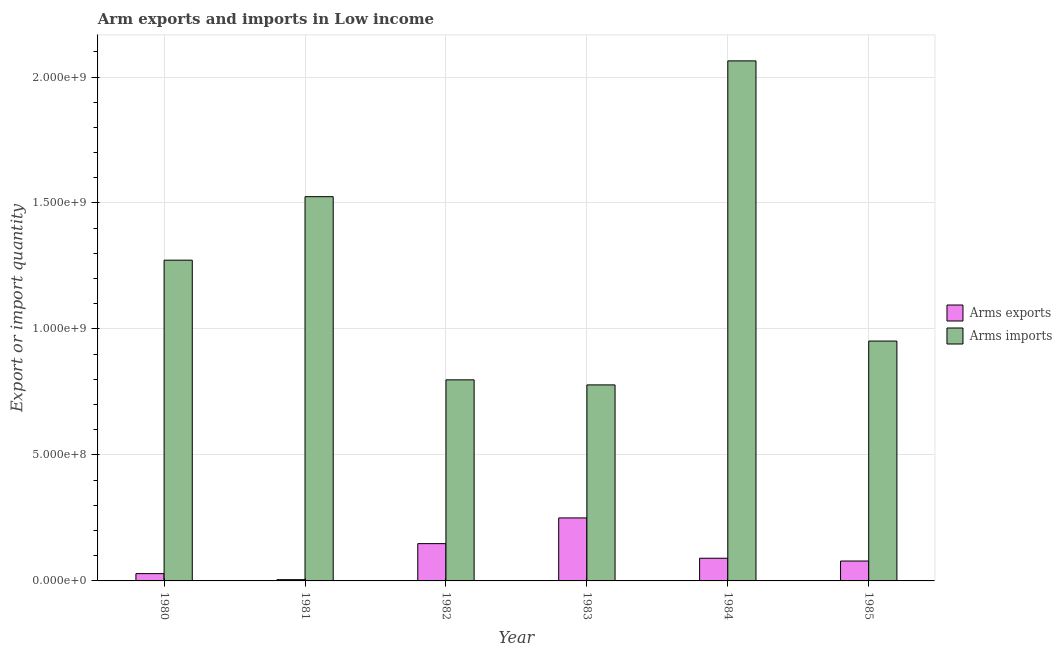How many different coloured bars are there?
Offer a very short reply. 2. How many groups of bars are there?
Make the answer very short. 6. Are the number of bars per tick equal to the number of legend labels?
Give a very brief answer. Yes. What is the label of the 6th group of bars from the left?
Your answer should be very brief. 1985. In how many cases, is the number of bars for a given year not equal to the number of legend labels?
Provide a short and direct response. 0. What is the arms exports in 1981?
Give a very brief answer. 5.00e+06. Across all years, what is the maximum arms imports?
Give a very brief answer. 2.06e+09. Across all years, what is the minimum arms exports?
Make the answer very short. 5.00e+06. In which year was the arms exports maximum?
Give a very brief answer. 1983. What is the total arms exports in the graph?
Your answer should be compact. 6.01e+08. What is the difference between the arms exports in 1980 and that in 1983?
Ensure brevity in your answer.  -2.21e+08. What is the difference between the arms imports in 1984 and the arms exports in 1982?
Ensure brevity in your answer.  1.27e+09. What is the average arms exports per year?
Your response must be concise. 1.00e+08. In how many years, is the arms exports greater than 900000000?
Make the answer very short. 0. What is the ratio of the arms imports in 1982 to that in 1985?
Keep it short and to the point. 0.84. Is the difference between the arms imports in 1980 and 1984 greater than the difference between the arms exports in 1980 and 1984?
Provide a short and direct response. No. What is the difference between the highest and the second highest arms exports?
Your answer should be compact. 1.02e+08. What is the difference between the highest and the lowest arms imports?
Offer a terse response. 1.29e+09. In how many years, is the arms exports greater than the average arms exports taken over all years?
Offer a very short reply. 2. Is the sum of the arms exports in 1981 and 1983 greater than the maximum arms imports across all years?
Your answer should be very brief. Yes. What does the 2nd bar from the left in 1984 represents?
Provide a short and direct response. Arms imports. What does the 1st bar from the right in 1981 represents?
Make the answer very short. Arms imports. Are all the bars in the graph horizontal?
Your response must be concise. No. What is the difference between two consecutive major ticks on the Y-axis?
Make the answer very short. 5.00e+08. Are the values on the major ticks of Y-axis written in scientific E-notation?
Make the answer very short. Yes. Where does the legend appear in the graph?
Make the answer very short. Center right. How many legend labels are there?
Offer a very short reply. 2. What is the title of the graph?
Keep it short and to the point. Arm exports and imports in Low income. What is the label or title of the X-axis?
Your answer should be very brief. Year. What is the label or title of the Y-axis?
Make the answer very short. Export or import quantity. What is the Export or import quantity in Arms exports in 1980?
Your answer should be very brief. 2.90e+07. What is the Export or import quantity of Arms imports in 1980?
Your answer should be compact. 1.27e+09. What is the Export or import quantity in Arms imports in 1981?
Your answer should be very brief. 1.52e+09. What is the Export or import quantity of Arms exports in 1982?
Offer a terse response. 1.48e+08. What is the Export or import quantity in Arms imports in 1982?
Your answer should be very brief. 7.98e+08. What is the Export or import quantity of Arms exports in 1983?
Ensure brevity in your answer.  2.50e+08. What is the Export or import quantity of Arms imports in 1983?
Your answer should be compact. 7.78e+08. What is the Export or import quantity of Arms exports in 1984?
Your answer should be very brief. 9.00e+07. What is the Export or import quantity of Arms imports in 1984?
Ensure brevity in your answer.  2.06e+09. What is the Export or import quantity of Arms exports in 1985?
Your answer should be very brief. 7.90e+07. What is the Export or import quantity in Arms imports in 1985?
Your answer should be compact. 9.52e+08. Across all years, what is the maximum Export or import quantity in Arms exports?
Keep it short and to the point. 2.50e+08. Across all years, what is the maximum Export or import quantity in Arms imports?
Provide a succinct answer. 2.06e+09. Across all years, what is the minimum Export or import quantity of Arms exports?
Provide a succinct answer. 5.00e+06. Across all years, what is the minimum Export or import quantity of Arms imports?
Give a very brief answer. 7.78e+08. What is the total Export or import quantity in Arms exports in the graph?
Your answer should be compact. 6.01e+08. What is the total Export or import quantity in Arms imports in the graph?
Ensure brevity in your answer.  7.39e+09. What is the difference between the Export or import quantity in Arms exports in 1980 and that in 1981?
Give a very brief answer. 2.40e+07. What is the difference between the Export or import quantity in Arms imports in 1980 and that in 1981?
Your response must be concise. -2.52e+08. What is the difference between the Export or import quantity in Arms exports in 1980 and that in 1982?
Make the answer very short. -1.19e+08. What is the difference between the Export or import quantity of Arms imports in 1980 and that in 1982?
Offer a terse response. 4.75e+08. What is the difference between the Export or import quantity of Arms exports in 1980 and that in 1983?
Give a very brief answer. -2.21e+08. What is the difference between the Export or import quantity of Arms imports in 1980 and that in 1983?
Give a very brief answer. 4.95e+08. What is the difference between the Export or import quantity in Arms exports in 1980 and that in 1984?
Ensure brevity in your answer.  -6.10e+07. What is the difference between the Export or import quantity of Arms imports in 1980 and that in 1984?
Offer a very short reply. -7.91e+08. What is the difference between the Export or import quantity in Arms exports in 1980 and that in 1985?
Provide a short and direct response. -5.00e+07. What is the difference between the Export or import quantity of Arms imports in 1980 and that in 1985?
Your answer should be compact. 3.21e+08. What is the difference between the Export or import quantity of Arms exports in 1981 and that in 1982?
Your answer should be compact. -1.43e+08. What is the difference between the Export or import quantity in Arms imports in 1981 and that in 1982?
Give a very brief answer. 7.27e+08. What is the difference between the Export or import quantity of Arms exports in 1981 and that in 1983?
Provide a succinct answer. -2.45e+08. What is the difference between the Export or import quantity of Arms imports in 1981 and that in 1983?
Your answer should be compact. 7.47e+08. What is the difference between the Export or import quantity in Arms exports in 1981 and that in 1984?
Provide a short and direct response. -8.50e+07. What is the difference between the Export or import quantity of Arms imports in 1981 and that in 1984?
Provide a short and direct response. -5.39e+08. What is the difference between the Export or import quantity in Arms exports in 1981 and that in 1985?
Keep it short and to the point. -7.40e+07. What is the difference between the Export or import quantity in Arms imports in 1981 and that in 1985?
Offer a very short reply. 5.73e+08. What is the difference between the Export or import quantity of Arms exports in 1982 and that in 1983?
Ensure brevity in your answer.  -1.02e+08. What is the difference between the Export or import quantity of Arms imports in 1982 and that in 1983?
Give a very brief answer. 2.00e+07. What is the difference between the Export or import quantity of Arms exports in 1982 and that in 1984?
Provide a succinct answer. 5.80e+07. What is the difference between the Export or import quantity in Arms imports in 1982 and that in 1984?
Ensure brevity in your answer.  -1.27e+09. What is the difference between the Export or import quantity of Arms exports in 1982 and that in 1985?
Your answer should be compact. 6.90e+07. What is the difference between the Export or import quantity in Arms imports in 1982 and that in 1985?
Give a very brief answer. -1.54e+08. What is the difference between the Export or import quantity of Arms exports in 1983 and that in 1984?
Provide a succinct answer. 1.60e+08. What is the difference between the Export or import quantity of Arms imports in 1983 and that in 1984?
Your response must be concise. -1.29e+09. What is the difference between the Export or import quantity in Arms exports in 1983 and that in 1985?
Offer a very short reply. 1.71e+08. What is the difference between the Export or import quantity in Arms imports in 1983 and that in 1985?
Keep it short and to the point. -1.74e+08. What is the difference between the Export or import quantity in Arms exports in 1984 and that in 1985?
Your response must be concise. 1.10e+07. What is the difference between the Export or import quantity of Arms imports in 1984 and that in 1985?
Provide a short and direct response. 1.11e+09. What is the difference between the Export or import quantity in Arms exports in 1980 and the Export or import quantity in Arms imports in 1981?
Offer a very short reply. -1.50e+09. What is the difference between the Export or import quantity in Arms exports in 1980 and the Export or import quantity in Arms imports in 1982?
Your response must be concise. -7.69e+08. What is the difference between the Export or import quantity of Arms exports in 1980 and the Export or import quantity of Arms imports in 1983?
Your answer should be very brief. -7.49e+08. What is the difference between the Export or import quantity in Arms exports in 1980 and the Export or import quantity in Arms imports in 1984?
Your answer should be very brief. -2.04e+09. What is the difference between the Export or import quantity in Arms exports in 1980 and the Export or import quantity in Arms imports in 1985?
Your answer should be very brief. -9.23e+08. What is the difference between the Export or import quantity in Arms exports in 1981 and the Export or import quantity in Arms imports in 1982?
Offer a terse response. -7.93e+08. What is the difference between the Export or import quantity in Arms exports in 1981 and the Export or import quantity in Arms imports in 1983?
Your response must be concise. -7.73e+08. What is the difference between the Export or import quantity of Arms exports in 1981 and the Export or import quantity of Arms imports in 1984?
Offer a terse response. -2.06e+09. What is the difference between the Export or import quantity in Arms exports in 1981 and the Export or import quantity in Arms imports in 1985?
Provide a succinct answer. -9.47e+08. What is the difference between the Export or import quantity of Arms exports in 1982 and the Export or import quantity of Arms imports in 1983?
Your answer should be compact. -6.30e+08. What is the difference between the Export or import quantity in Arms exports in 1982 and the Export or import quantity in Arms imports in 1984?
Make the answer very short. -1.92e+09. What is the difference between the Export or import quantity in Arms exports in 1982 and the Export or import quantity in Arms imports in 1985?
Your response must be concise. -8.04e+08. What is the difference between the Export or import quantity in Arms exports in 1983 and the Export or import quantity in Arms imports in 1984?
Your answer should be very brief. -1.81e+09. What is the difference between the Export or import quantity in Arms exports in 1983 and the Export or import quantity in Arms imports in 1985?
Offer a terse response. -7.02e+08. What is the difference between the Export or import quantity of Arms exports in 1984 and the Export or import quantity of Arms imports in 1985?
Provide a short and direct response. -8.62e+08. What is the average Export or import quantity of Arms exports per year?
Offer a very short reply. 1.00e+08. What is the average Export or import quantity of Arms imports per year?
Provide a short and direct response. 1.23e+09. In the year 1980, what is the difference between the Export or import quantity in Arms exports and Export or import quantity in Arms imports?
Give a very brief answer. -1.24e+09. In the year 1981, what is the difference between the Export or import quantity of Arms exports and Export or import quantity of Arms imports?
Offer a very short reply. -1.52e+09. In the year 1982, what is the difference between the Export or import quantity in Arms exports and Export or import quantity in Arms imports?
Provide a succinct answer. -6.50e+08. In the year 1983, what is the difference between the Export or import quantity in Arms exports and Export or import quantity in Arms imports?
Offer a very short reply. -5.28e+08. In the year 1984, what is the difference between the Export or import quantity of Arms exports and Export or import quantity of Arms imports?
Give a very brief answer. -1.97e+09. In the year 1985, what is the difference between the Export or import quantity in Arms exports and Export or import quantity in Arms imports?
Keep it short and to the point. -8.73e+08. What is the ratio of the Export or import quantity in Arms imports in 1980 to that in 1981?
Give a very brief answer. 0.83. What is the ratio of the Export or import quantity of Arms exports in 1980 to that in 1982?
Provide a succinct answer. 0.2. What is the ratio of the Export or import quantity in Arms imports in 1980 to that in 1982?
Give a very brief answer. 1.6. What is the ratio of the Export or import quantity in Arms exports in 1980 to that in 1983?
Offer a terse response. 0.12. What is the ratio of the Export or import quantity in Arms imports in 1980 to that in 1983?
Your answer should be compact. 1.64. What is the ratio of the Export or import quantity of Arms exports in 1980 to that in 1984?
Give a very brief answer. 0.32. What is the ratio of the Export or import quantity in Arms imports in 1980 to that in 1984?
Make the answer very short. 0.62. What is the ratio of the Export or import quantity of Arms exports in 1980 to that in 1985?
Offer a terse response. 0.37. What is the ratio of the Export or import quantity of Arms imports in 1980 to that in 1985?
Give a very brief answer. 1.34. What is the ratio of the Export or import quantity of Arms exports in 1981 to that in 1982?
Your answer should be very brief. 0.03. What is the ratio of the Export or import quantity in Arms imports in 1981 to that in 1982?
Your response must be concise. 1.91. What is the ratio of the Export or import quantity of Arms imports in 1981 to that in 1983?
Provide a succinct answer. 1.96. What is the ratio of the Export or import quantity in Arms exports in 1981 to that in 1984?
Give a very brief answer. 0.06. What is the ratio of the Export or import quantity of Arms imports in 1981 to that in 1984?
Give a very brief answer. 0.74. What is the ratio of the Export or import quantity in Arms exports in 1981 to that in 1985?
Your answer should be compact. 0.06. What is the ratio of the Export or import quantity in Arms imports in 1981 to that in 1985?
Keep it short and to the point. 1.6. What is the ratio of the Export or import quantity in Arms exports in 1982 to that in 1983?
Ensure brevity in your answer.  0.59. What is the ratio of the Export or import quantity in Arms imports in 1982 to that in 1983?
Your response must be concise. 1.03. What is the ratio of the Export or import quantity of Arms exports in 1982 to that in 1984?
Offer a terse response. 1.64. What is the ratio of the Export or import quantity of Arms imports in 1982 to that in 1984?
Ensure brevity in your answer.  0.39. What is the ratio of the Export or import quantity of Arms exports in 1982 to that in 1985?
Your answer should be compact. 1.87. What is the ratio of the Export or import quantity of Arms imports in 1982 to that in 1985?
Offer a very short reply. 0.84. What is the ratio of the Export or import quantity of Arms exports in 1983 to that in 1984?
Give a very brief answer. 2.78. What is the ratio of the Export or import quantity of Arms imports in 1983 to that in 1984?
Keep it short and to the point. 0.38. What is the ratio of the Export or import quantity in Arms exports in 1983 to that in 1985?
Keep it short and to the point. 3.16. What is the ratio of the Export or import quantity of Arms imports in 1983 to that in 1985?
Make the answer very short. 0.82. What is the ratio of the Export or import quantity in Arms exports in 1984 to that in 1985?
Offer a terse response. 1.14. What is the ratio of the Export or import quantity of Arms imports in 1984 to that in 1985?
Offer a terse response. 2.17. What is the difference between the highest and the second highest Export or import quantity of Arms exports?
Offer a very short reply. 1.02e+08. What is the difference between the highest and the second highest Export or import quantity in Arms imports?
Your response must be concise. 5.39e+08. What is the difference between the highest and the lowest Export or import quantity of Arms exports?
Give a very brief answer. 2.45e+08. What is the difference between the highest and the lowest Export or import quantity of Arms imports?
Give a very brief answer. 1.29e+09. 